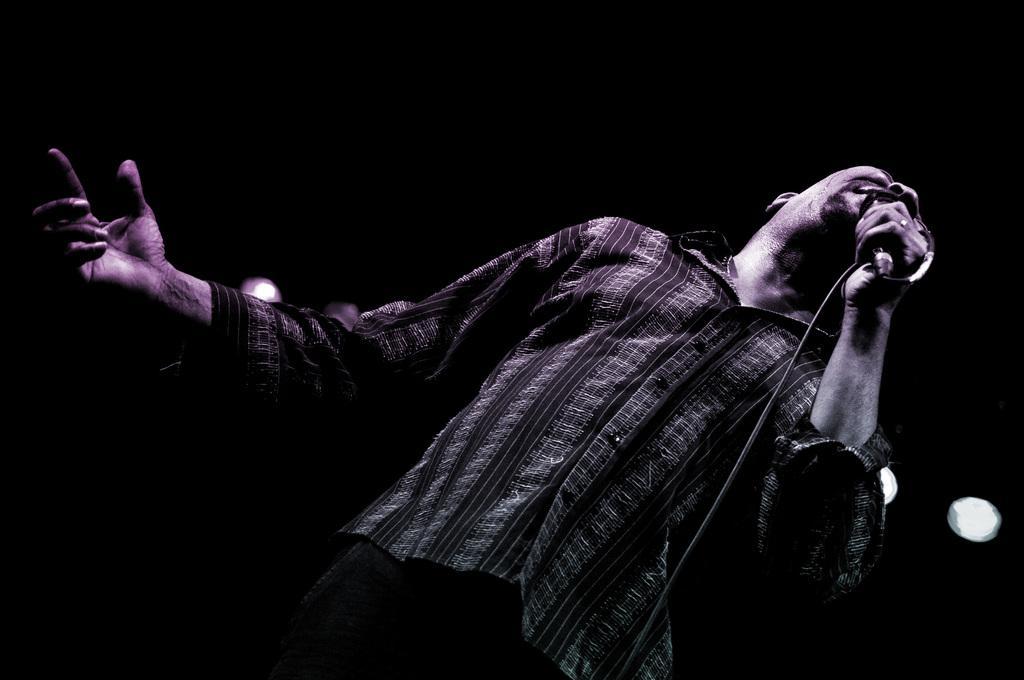Describe this image in one or two sentences. In this image we can see a man standing and holding a mic. In the background there are lights. 